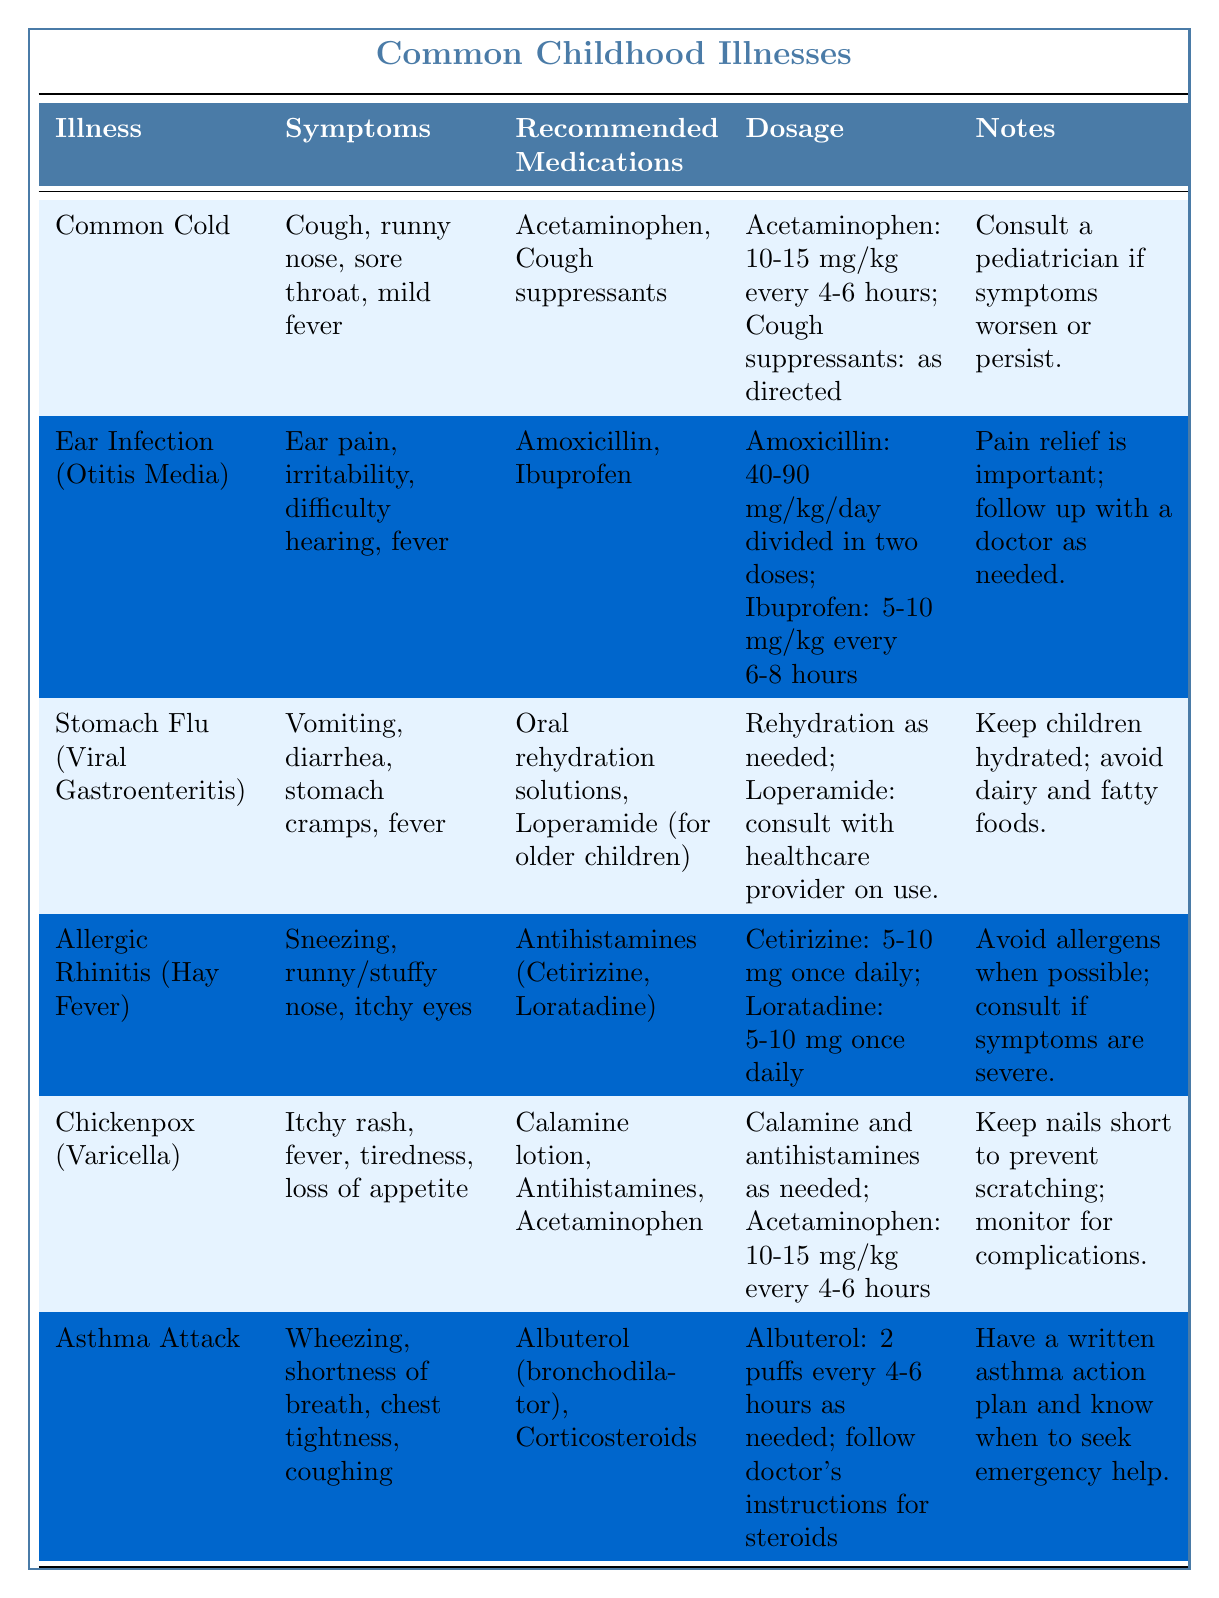What is the recommended medication for a Common Cold? The table specifies that the recommended medications for a Common Cold include Acetaminophen and Cough suppressants.
Answer: Acetaminophen, Cough suppressants What symptoms are associated with Ear Infection (Otitis Media)? The symptoms listed for Ear Infection (Otitis Media) are ear pain, irritability, difficulty hearing, and fever.
Answer: Ear pain, irritability, difficulty hearing, fever Which illness has Calamine lotion as a recommended medication? According to the table, Chickenpox (Varicella) has Calamine lotion listed as one of the recommended medications.
Answer: Chickenpox (Varicella) How often should Acetaminophen be given for a Common Cold? The dosage mentioned for Acetaminophen in the case of a Common Cold is 10-15 mg/kg every 4-6 hours.
Answer: Every 4-6 hours Is it true that Antihistamines can be used for Allergic Rhinitis? The table confirms that Antihistamines such as Cetirizine and Loratadine are recommended for managing Allergic Rhinitis.
Answer: Yes What are the symptoms of Stomach Flu (Viral Gastroenteritis)? Symptoms for Stomach Flu (Viral Gastroenteritis) include vomiting, diarrhea, stomach cramps, and fever as listed in the table.
Answer: Vomiting, diarrhea, stomach cramps, fever Which two illnesses involve giving Ibuprofen for pain relief? Both Ear Infection (Otitis Media) and Stomach Flu (Viral Gastroenteritis) have Ibuprofen listed as a recommended medication for pain relief.
Answer: Ear Infection, Stomach Flu If a child has difficulty breathing and chest tightness, which illness might they be experiencing? The symptoms of wheezing, shortness of breath, chest tightness, and coughing are indicative of an Asthma Attack according to the table.
Answer: Asthma Attack How many hours apart can Albuterol be administered? The table states that Albuterol can be given every 4-6 hours as needed, so it can be administered multiple times a day based on the child's requirement.
Answer: Every 4-6 hours Which illness is associated with keeping nails short to prevent scratching? The table notes that keeping nails short is particularly important for managing Chickenpox (Varicella) to prevent scratching the itchy rash.
Answer: Chickenpox (Varicella) What is the dosage of Loperamide for older children during Stomach Flu? The table suggests consulting with a healthcare provider regarding the use of Loperamide for older children, indicating that specific dosages should be determined by a professional.
Answer: Consult healthcare provider Compare the dosages of Acetaminophen and Ibuprofen for managing Ear Infection. For Ear Infection, Acetaminophen is given at a dosage of 40-90 mg/kg/day divided into two doses, while Ibuprofen is given at 5-10 mg/kg every 6-8 hours. This shows the frequency and amount differ significantly.
Answer: Acetaminophen: 40-90 mg/kg/day; Ibuprofen: 5-10 mg/kg every 6-8 hours How do the symptoms of Chickenpox differ from those of a Common Cold? Chickenpox involves an itchy rash, fever, tiredness, and loss of appetite, while a Common Cold includes cough, runny nose, sore throat, and mild fever. Therefore, the key difference is the presence of a rash in Chickenpox.
Answer: Chickenpox includes an itchy rash; Common Cold does not 